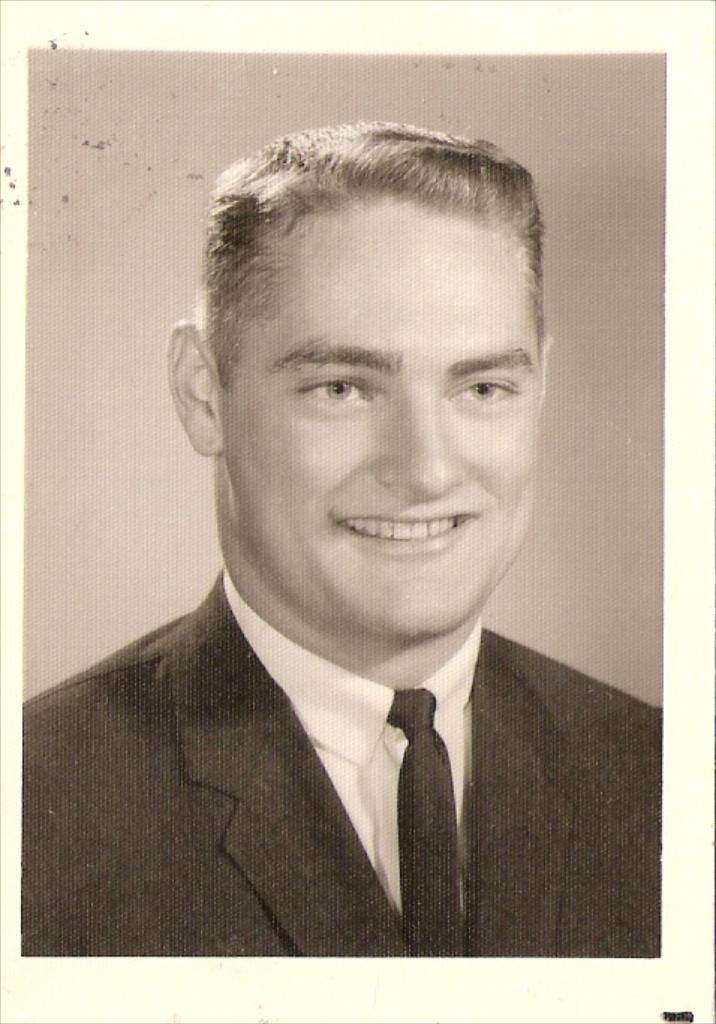What is the color scheme of the image? The image is black and white. What is the main subject of the image? There is a photo of a person in the image. What is the person in the photo doing? The person in the photo is smiling. What is the person in the photo wearing? The person in the photo is wearing a suit. How many snails can be seen crawling on the person's suit in the image? There are no snails visible in the image; the person is wearing a suit, but there are no snails present. What type of station is depicted in the background of the image? There is no station depicted in the image; it features a photo of a person wearing a suit and smiling. 